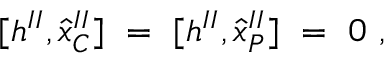<formula> <loc_0><loc_0><loc_500><loc_500>[ h ^ { I I } , { \hat { x } } _ { C } ^ { I I } ] \ = \ [ h ^ { I I } , { \hat { x } } _ { P } ^ { I I } ] \ = \ 0 \ ,</formula> 